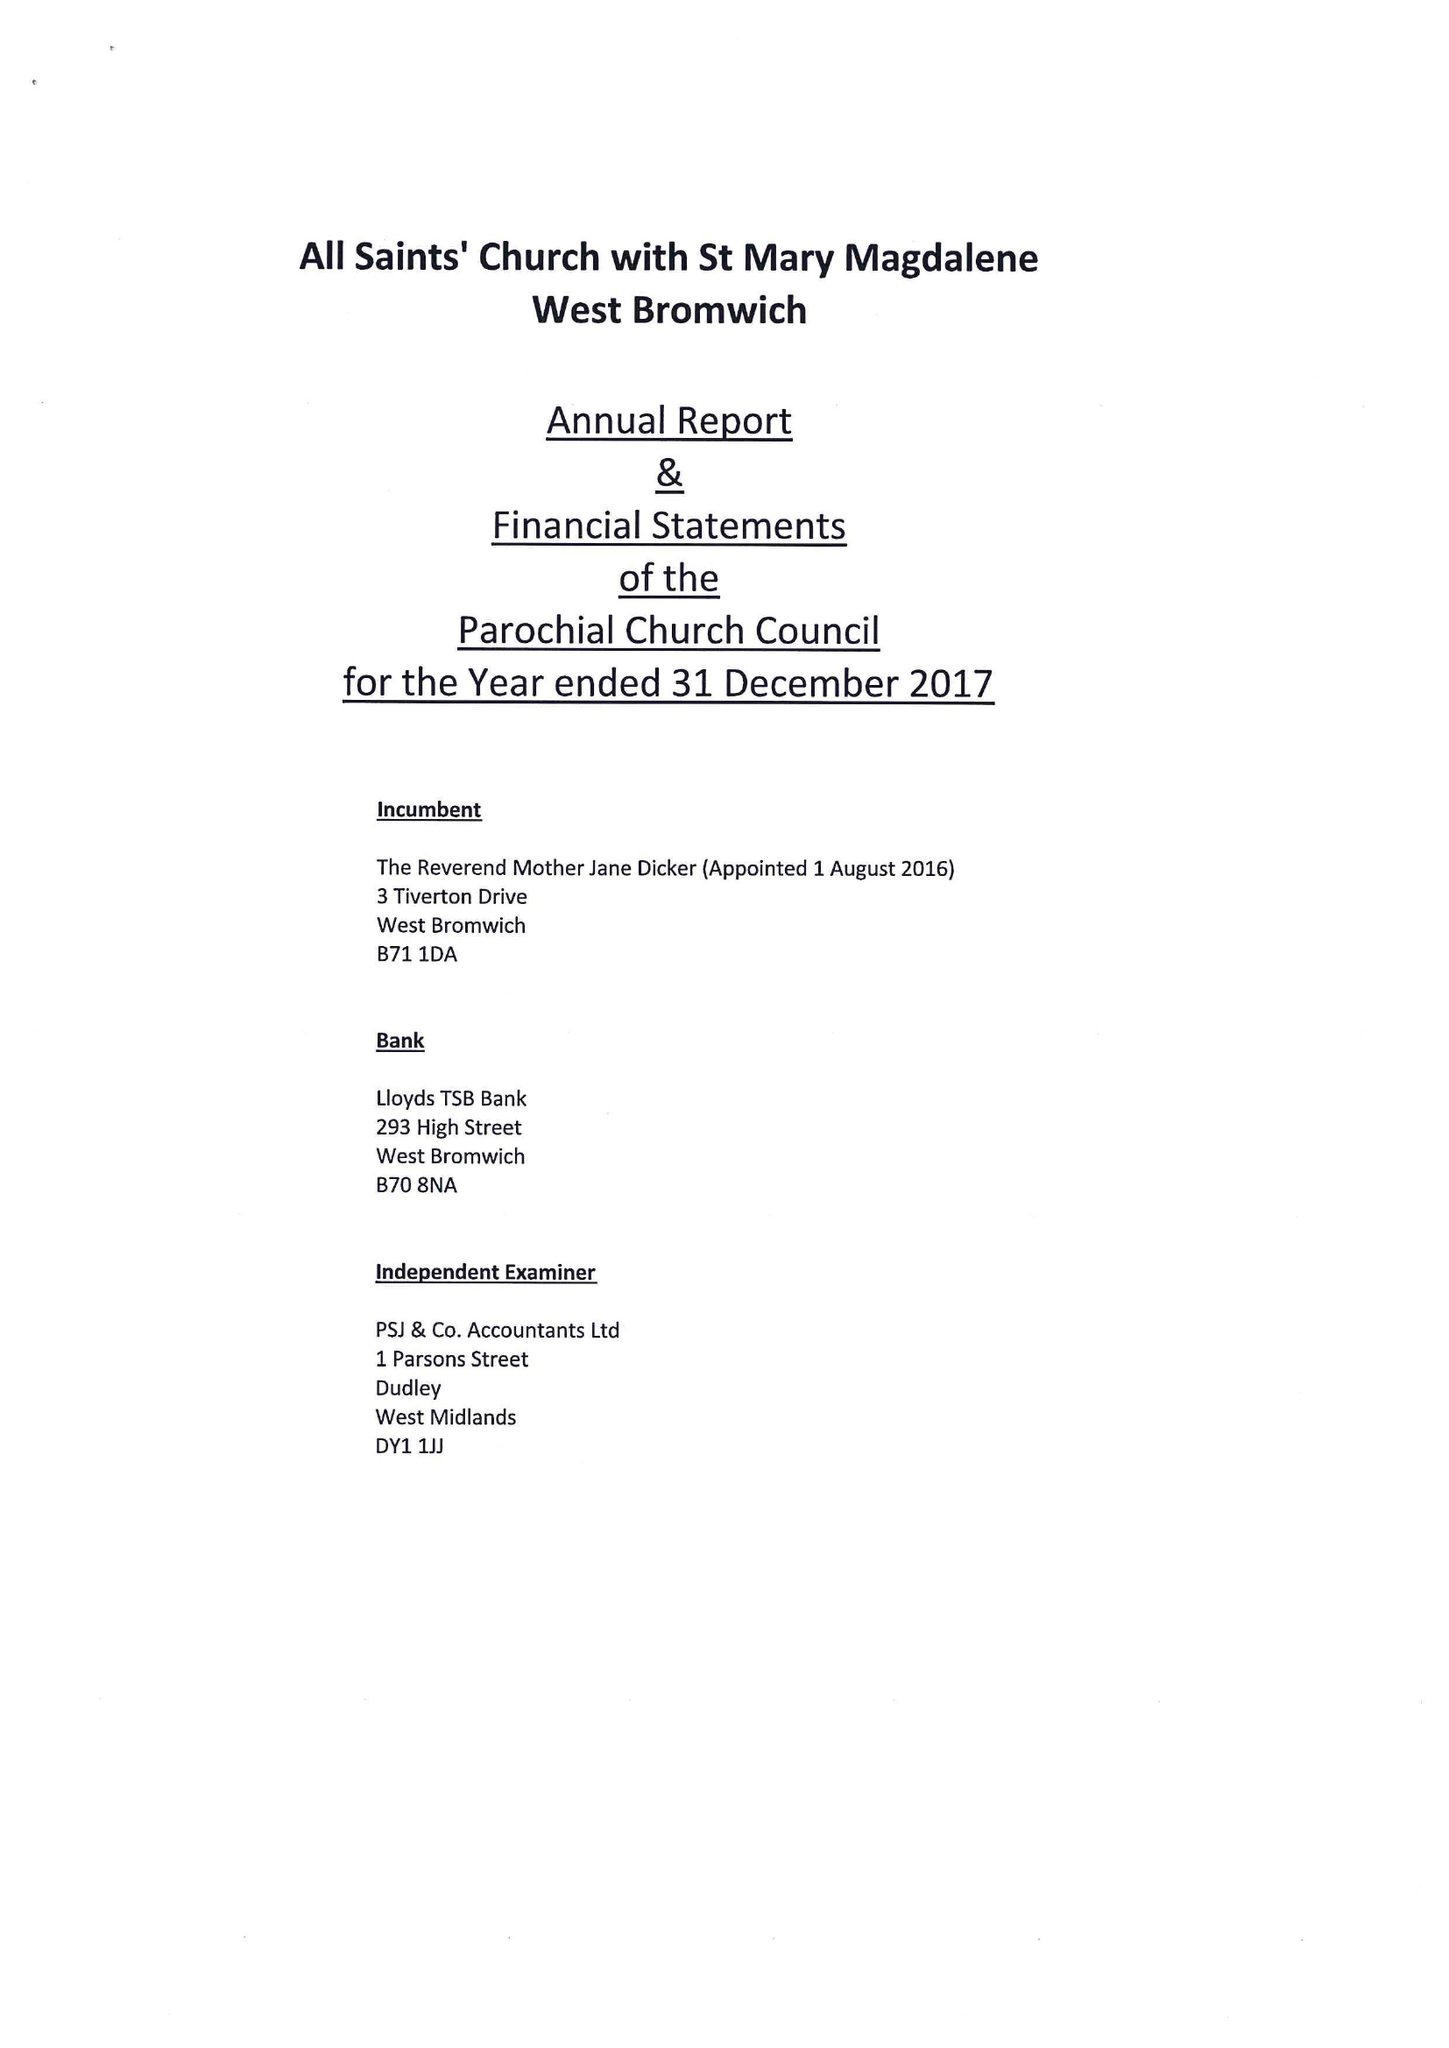What is the value for the address__street_line?
Answer the question using a single word or phrase. 38 PEAR TREE DRIVE 